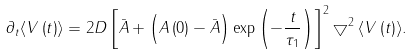<formula> <loc_0><loc_0><loc_500><loc_500>\partial _ { t } \langle V \left ( t \right ) \rangle = 2 D \left [ \bar { A } + \left ( A \left ( 0 \right ) - \bar { A } \right ) \exp \left ( - \frac { t } { \tau _ { 1 } } \right ) \right ] ^ { 2 } \bigtriangledown ^ { 2 } \langle V \left ( t \right ) \rangle .</formula> 